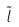<formula> <loc_0><loc_0><loc_500><loc_500>\tilde { l }</formula> 